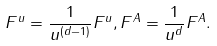<formula> <loc_0><loc_0><loc_500><loc_500>F ^ { u } = \frac { 1 } { u ^ { \left ( d - 1 \right ) } } F ^ { u } , F ^ { A } = \frac { 1 } { u ^ { d } } F ^ { A } .</formula> 